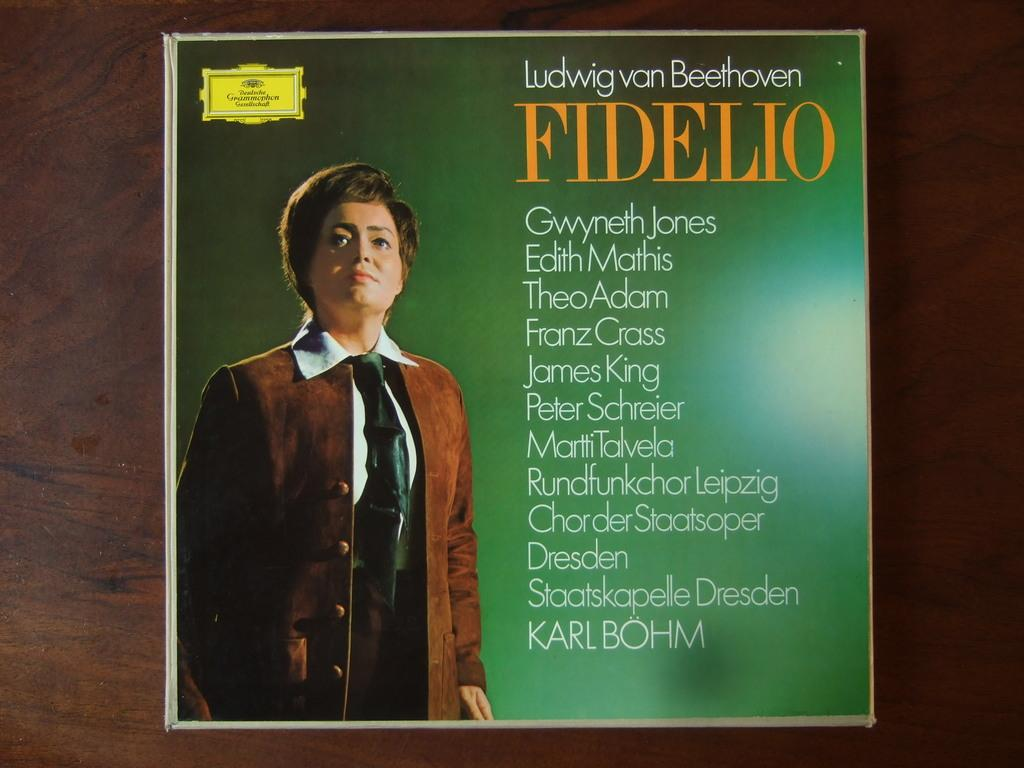<image>
Render a clear and concise summary of the photo. A Ludwig van Beethoven record sitting on a wooden table. 